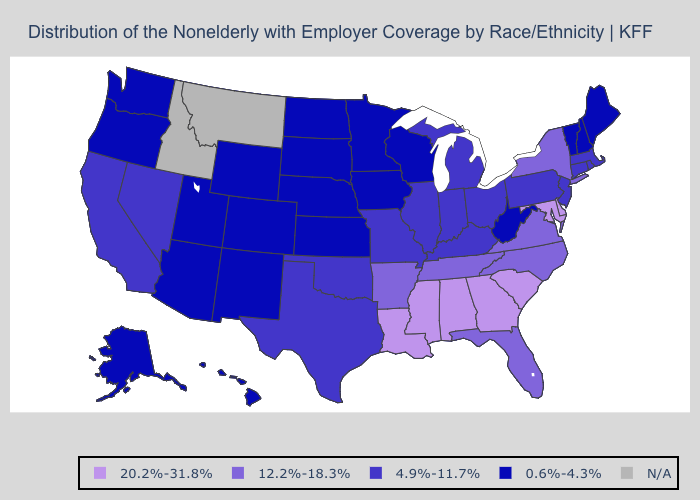Among the states that border Oregon , which have the highest value?
Quick response, please. California, Nevada. Does the map have missing data?
Answer briefly. Yes. What is the value of Alaska?
Quick response, please. 0.6%-4.3%. How many symbols are there in the legend?
Keep it brief. 5. Which states hav the highest value in the South?
Keep it brief. Alabama, Delaware, Georgia, Louisiana, Maryland, Mississippi, South Carolina. Among the states that border Missouri , does Nebraska have the lowest value?
Quick response, please. Yes. Among the states that border Michigan , which have the highest value?
Concise answer only. Indiana, Ohio. How many symbols are there in the legend?
Concise answer only. 5. Among the states that border New Jersey , which have the highest value?
Concise answer only. Delaware. Does West Virginia have the lowest value in the USA?
Be succinct. Yes. What is the highest value in states that border Iowa?
Concise answer only. 4.9%-11.7%. Name the states that have a value in the range 0.6%-4.3%?
Short answer required. Alaska, Arizona, Colorado, Hawaii, Iowa, Kansas, Maine, Minnesota, Nebraska, New Hampshire, New Mexico, North Dakota, Oregon, South Dakota, Utah, Vermont, Washington, West Virginia, Wisconsin, Wyoming. Is the legend a continuous bar?
Concise answer only. No. What is the highest value in states that border Missouri?
Concise answer only. 12.2%-18.3%. 